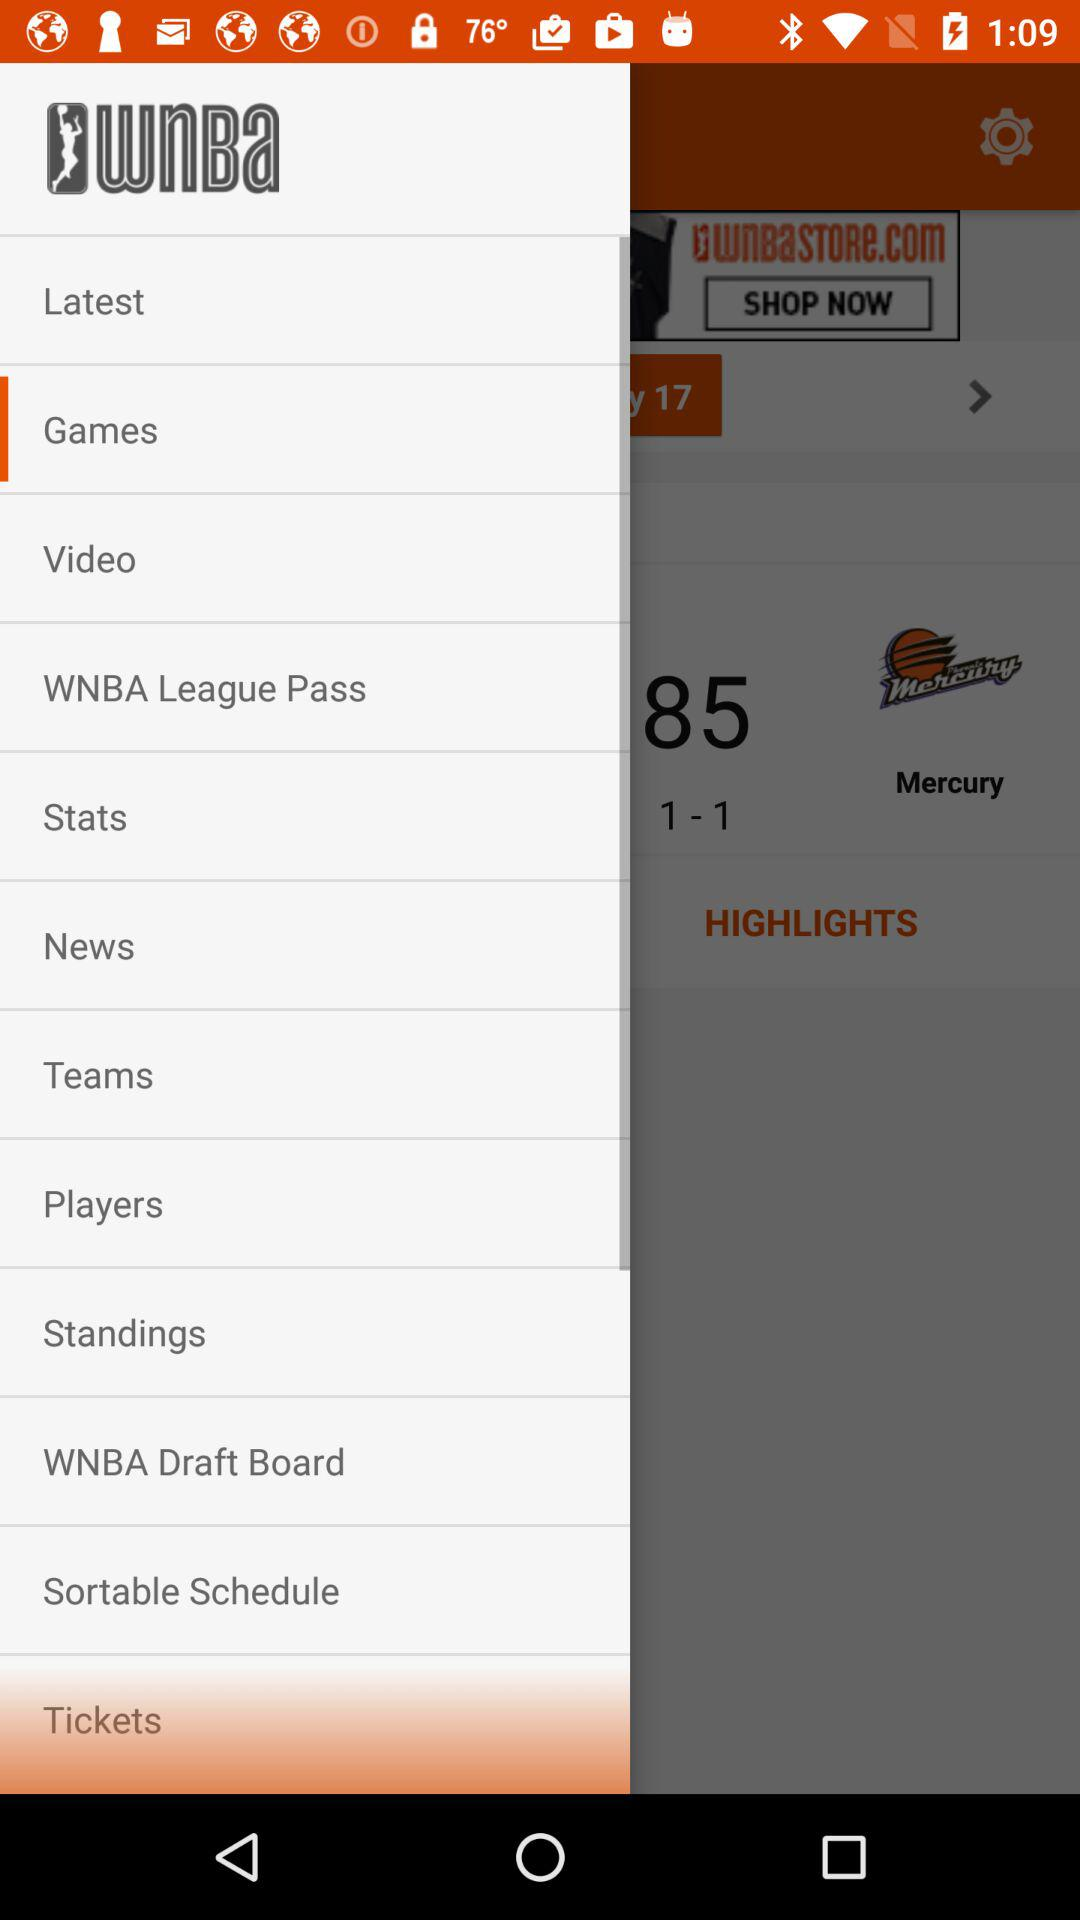What is the name of the application? The name of the application is "WNBA". 